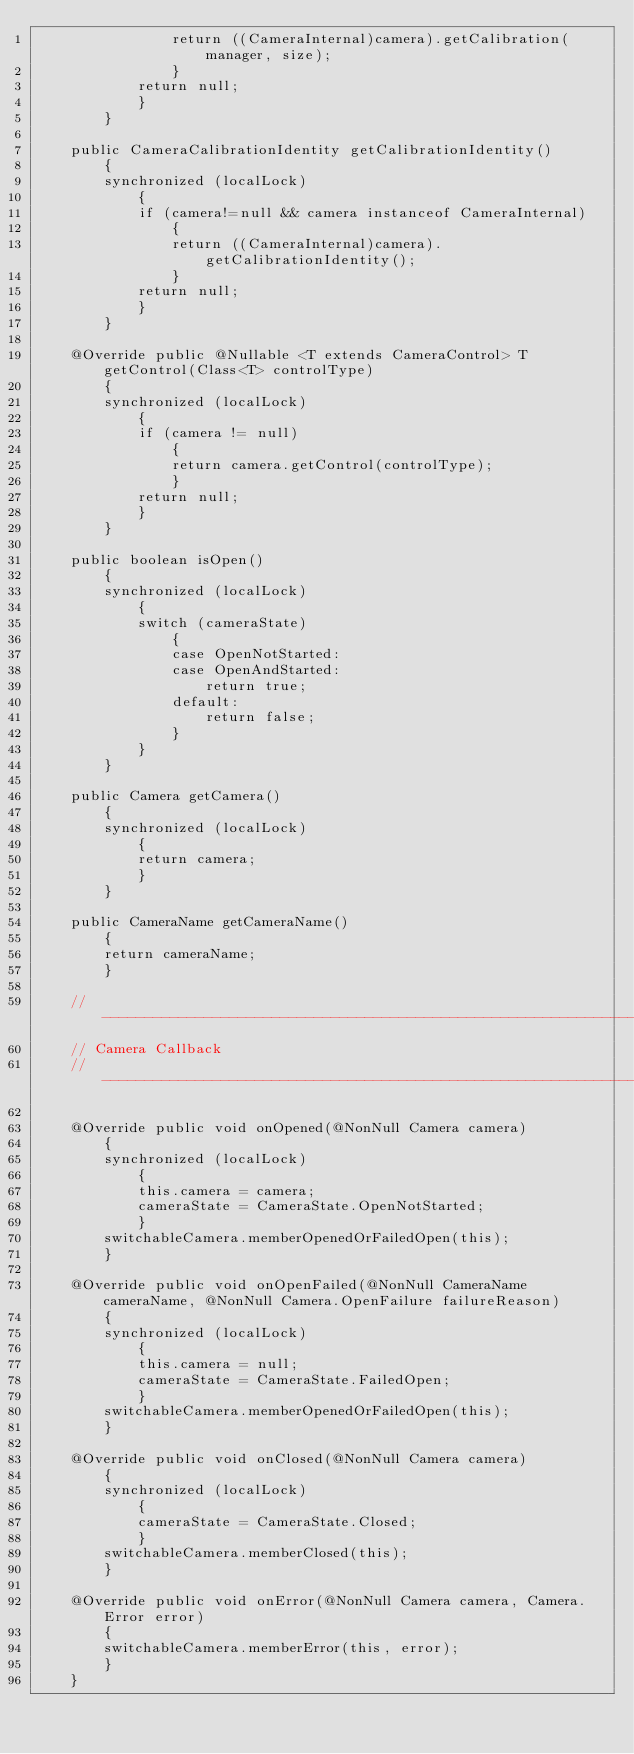<code> <loc_0><loc_0><loc_500><loc_500><_Java_>                return ((CameraInternal)camera).getCalibration(manager, size);
                }
            return null;
            }
        }

    public CameraCalibrationIdentity getCalibrationIdentity()
        {
        synchronized (localLock)
            {
            if (camera!=null && camera instanceof CameraInternal)
                {
                return ((CameraInternal)camera).getCalibrationIdentity();
                }
            return null;
            }
        }

    @Override public @Nullable <T extends CameraControl> T getControl(Class<T> controlType)
        {
        synchronized (localLock)
            {
            if (camera != null)
                {
                return camera.getControl(controlType);
                }
            return null;
            }
        }

    public boolean isOpen()
        {
        synchronized (localLock)
            {
            switch (cameraState)
                {
                case OpenNotStarted:
                case OpenAndStarted:
                    return true;
                default:
                    return false;
                }
            }
        }

    public Camera getCamera()
        {
        synchronized (localLock)
            {
            return camera;
            }
        }

    public CameraName getCameraName()
        {
        return cameraName;
        }

    //------------------------------------------------------------------------------------------
    // Camera Callback
    //------------------------------------------------------------------------------------------

    @Override public void onOpened(@NonNull Camera camera)
        {
        synchronized (localLock)
            {
            this.camera = camera;
            cameraState = CameraState.OpenNotStarted;
            }
        switchableCamera.memberOpenedOrFailedOpen(this);
        }

    @Override public void onOpenFailed(@NonNull CameraName cameraName, @NonNull Camera.OpenFailure failureReason)
        {
        synchronized (localLock)
            {
            this.camera = null;
            cameraState = CameraState.FailedOpen;
            }
        switchableCamera.memberOpenedOrFailedOpen(this);
        }

    @Override public void onClosed(@NonNull Camera camera)
        {
        synchronized (localLock)
            {
            cameraState = CameraState.Closed;
            }
        switchableCamera.memberClosed(this);
        }

    @Override public void onError(@NonNull Camera camera, Camera.Error error)
        {
        switchableCamera.memberError(this, error);
        }
    }
</code> 